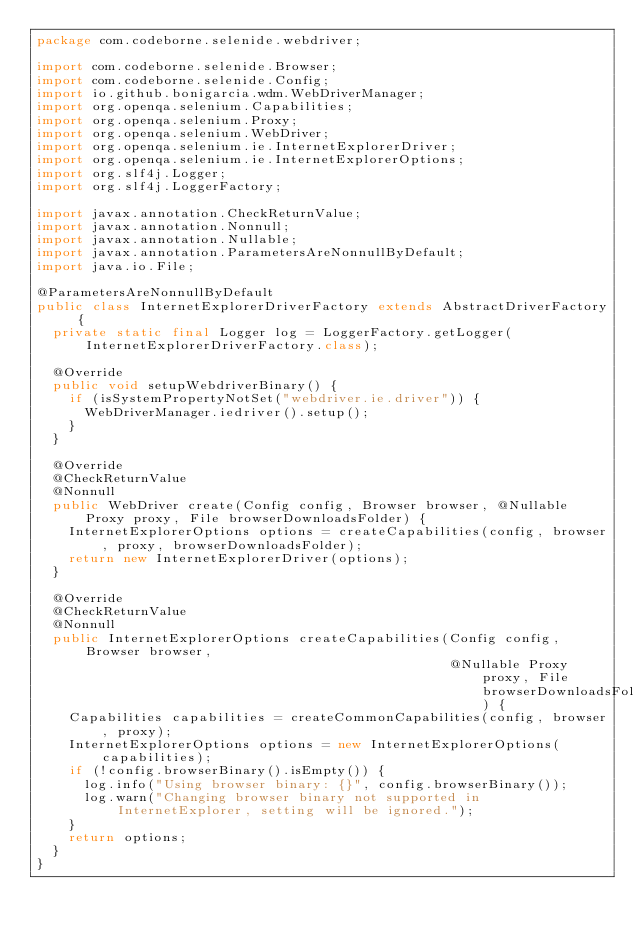<code> <loc_0><loc_0><loc_500><loc_500><_Java_>package com.codeborne.selenide.webdriver;

import com.codeborne.selenide.Browser;
import com.codeborne.selenide.Config;
import io.github.bonigarcia.wdm.WebDriverManager;
import org.openqa.selenium.Capabilities;
import org.openqa.selenium.Proxy;
import org.openqa.selenium.WebDriver;
import org.openqa.selenium.ie.InternetExplorerDriver;
import org.openqa.selenium.ie.InternetExplorerOptions;
import org.slf4j.Logger;
import org.slf4j.LoggerFactory;

import javax.annotation.CheckReturnValue;
import javax.annotation.Nonnull;
import javax.annotation.Nullable;
import javax.annotation.ParametersAreNonnullByDefault;
import java.io.File;

@ParametersAreNonnullByDefault
public class InternetExplorerDriverFactory extends AbstractDriverFactory {
  private static final Logger log = LoggerFactory.getLogger(InternetExplorerDriverFactory.class);

  @Override
  public void setupWebdriverBinary() {
    if (isSystemPropertyNotSet("webdriver.ie.driver")) {
      WebDriverManager.iedriver().setup();
    }
  }

  @Override
  @CheckReturnValue
  @Nonnull
  public WebDriver create(Config config, Browser browser, @Nullable Proxy proxy, File browserDownloadsFolder) {
    InternetExplorerOptions options = createCapabilities(config, browser, proxy, browserDownloadsFolder);
    return new InternetExplorerDriver(options);
  }

  @Override
  @CheckReturnValue
  @Nonnull
  public InternetExplorerOptions createCapabilities(Config config, Browser browser,
                                                    @Nullable Proxy proxy, File browserDownloadsFolder) {
    Capabilities capabilities = createCommonCapabilities(config, browser, proxy);
    InternetExplorerOptions options = new InternetExplorerOptions(capabilities);
    if (!config.browserBinary().isEmpty()) {
      log.info("Using browser binary: {}", config.browserBinary());
      log.warn("Changing browser binary not supported in InternetExplorer, setting will be ignored.");
    }
    return options;
  }
}
</code> 